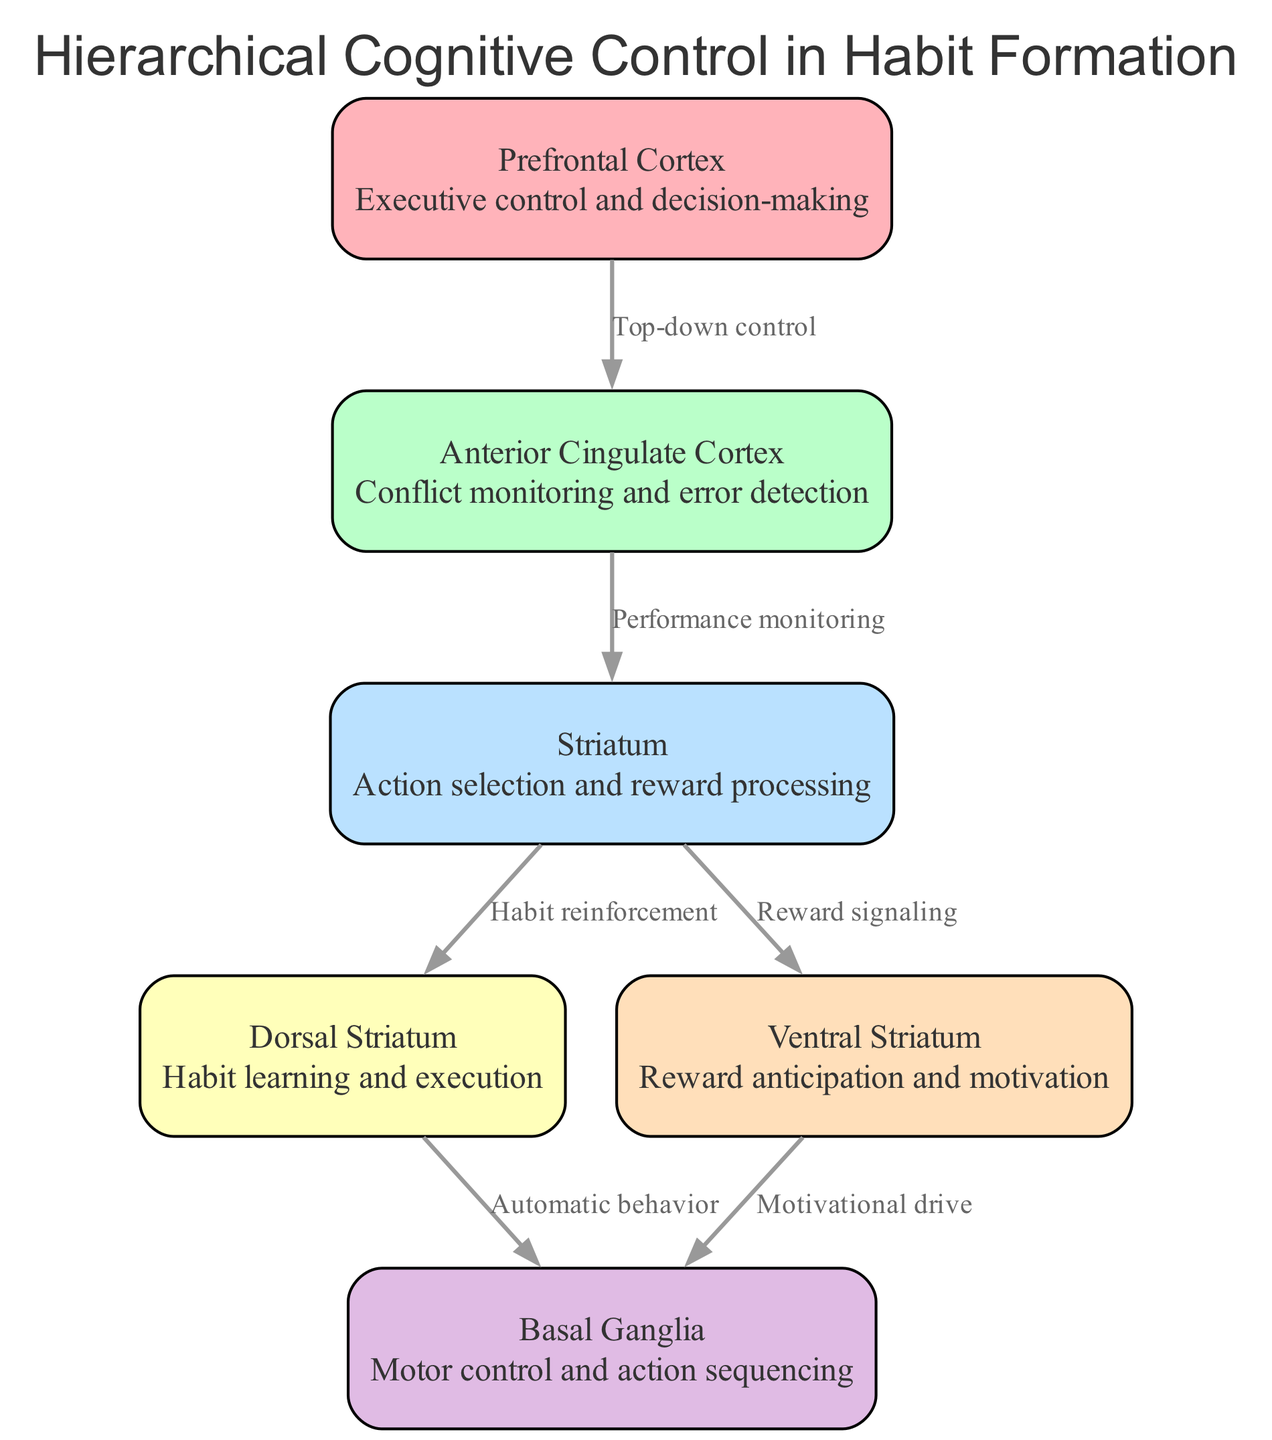What is the highest level of cognitive control in habit formation? According to the diagram, the first node at the top is "Prefrontal Cortex," which represents the highest level in the hierarchy for cognitive control in habit formation.
Answer: Prefrontal Cortex How many nodes are present in the diagram? The diagram consists of six nodes that represent different brain regions involved in cognitive control for habit formation.
Answer: 6 What is the relationship between the Anterior Cingulate Cortex and the Striatum? The diagram shows a directed edge from the Anterior Cingulate Cortex to the Striatum labeled "Performance monitoring," indicating that it's part of the flow of cognitive control.
Answer: Performance monitoring Which structure is primarily responsible for habit learning and execution? The diagram identifies the "Dorsal Striatum" as the node specifically related to the processes of habit learning and execution within the hierarchy.
Answer: Dorsal Striatum What kind of behavior does the Dorsal Striatum control? The directed edge from the Dorsal Striatum to the Basal Ganglia is labeled "Automatic behavior," indicating that the Dorsal Striatum is involved in the control of automatic behaviors related to habits.
Answer: Automatic behavior Which node indicates reward anticipation and motivation? The diagram shows the "Ventral Striatum" as the node that focuses on rewarding aspects, specifically anticipation and motivation connected to the habit formation process.
Answer: Ventral Striatum How does the Prefrontal Cortex influence other regions in the diagram? The Prefrontal Cortex exerts "Top-down control" over the Anterior Cingulate Cortex, indicating its role in guiding decision-making processes that affect lower levels of this cognitive control hierarchy.
Answer: Top-down control Which two nodes have a direct influence on the Basal Ganglia? Both the Dorsal Striatum and the Ventral Striatum are connected directly to the Basal Ganglia, with edges labeled "Automatic behavior" and "Motivational drive," respectively, which highlights their roles in action sequencing.
Answer: Dorsal Striatum and Ventral Striatum 